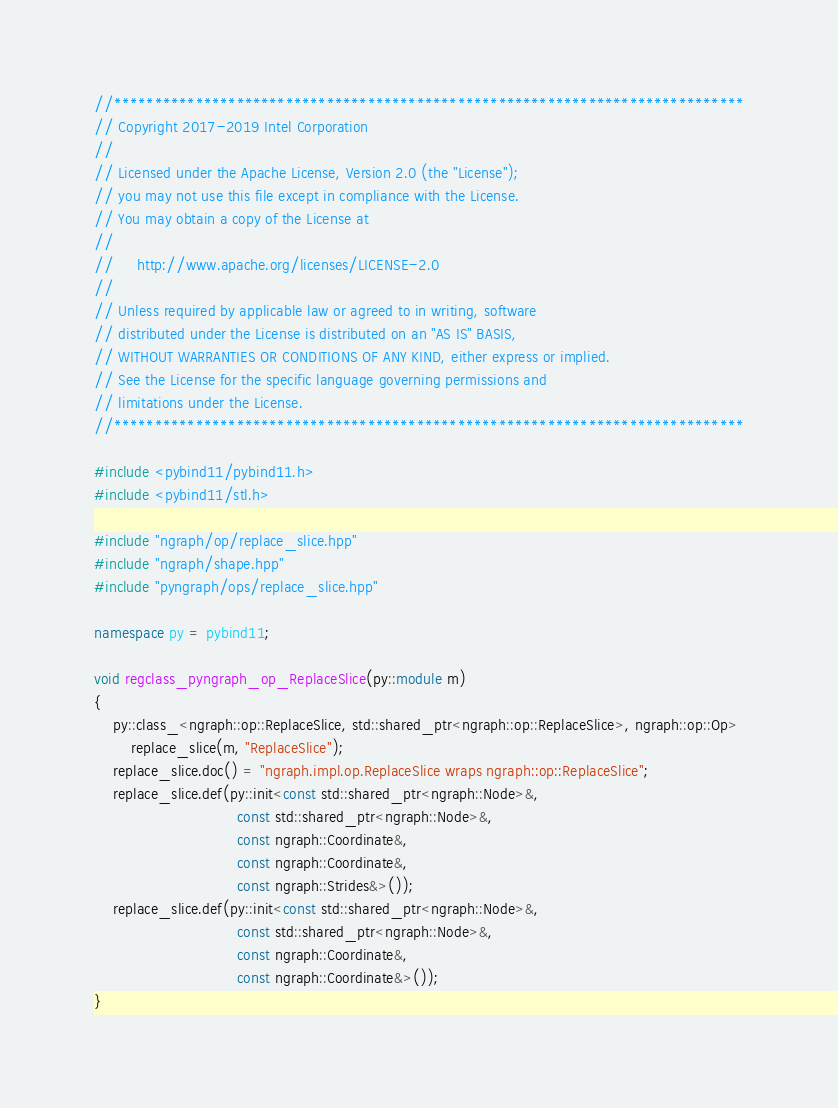<code> <loc_0><loc_0><loc_500><loc_500><_C++_>//*****************************************************************************
// Copyright 2017-2019 Intel Corporation
//
// Licensed under the Apache License, Version 2.0 (the "License");
// you may not use this file except in compliance with the License.
// You may obtain a copy of the License at
//
//     http://www.apache.org/licenses/LICENSE-2.0
//
// Unless required by applicable law or agreed to in writing, software
// distributed under the License is distributed on an "AS IS" BASIS,
// WITHOUT WARRANTIES OR CONDITIONS OF ANY KIND, either express or implied.
// See the License for the specific language governing permissions and
// limitations under the License.
//*****************************************************************************

#include <pybind11/pybind11.h>
#include <pybind11/stl.h>

#include "ngraph/op/replace_slice.hpp"
#include "ngraph/shape.hpp"
#include "pyngraph/ops/replace_slice.hpp"

namespace py = pybind11;

void regclass_pyngraph_op_ReplaceSlice(py::module m)
{
    py::class_<ngraph::op::ReplaceSlice, std::shared_ptr<ngraph::op::ReplaceSlice>, ngraph::op::Op>
        replace_slice(m, "ReplaceSlice");
    replace_slice.doc() = "ngraph.impl.op.ReplaceSlice wraps ngraph::op::ReplaceSlice";
    replace_slice.def(py::init<const std::shared_ptr<ngraph::Node>&,
                               const std::shared_ptr<ngraph::Node>&,
                               const ngraph::Coordinate&,
                               const ngraph::Coordinate&,
                               const ngraph::Strides&>());
    replace_slice.def(py::init<const std::shared_ptr<ngraph::Node>&,
                               const std::shared_ptr<ngraph::Node>&,
                               const ngraph::Coordinate&,
                               const ngraph::Coordinate&>());
}
</code> 